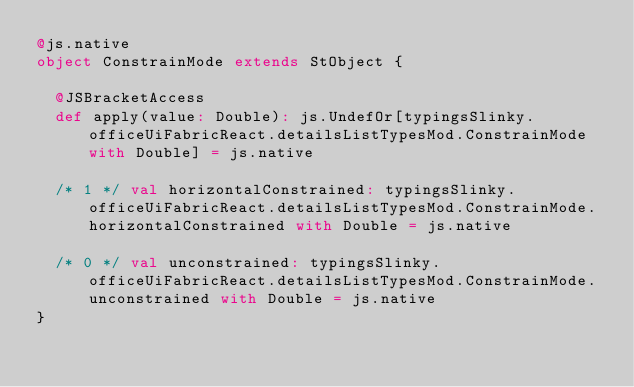<code> <loc_0><loc_0><loc_500><loc_500><_Scala_>@js.native
object ConstrainMode extends StObject {
  
  @JSBracketAccess
  def apply(value: Double): js.UndefOr[typingsSlinky.officeUiFabricReact.detailsListTypesMod.ConstrainMode with Double] = js.native
  
  /* 1 */ val horizontalConstrained: typingsSlinky.officeUiFabricReact.detailsListTypesMod.ConstrainMode.horizontalConstrained with Double = js.native
  
  /* 0 */ val unconstrained: typingsSlinky.officeUiFabricReact.detailsListTypesMod.ConstrainMode.unconstrained with Double = js.native
}
</code> 